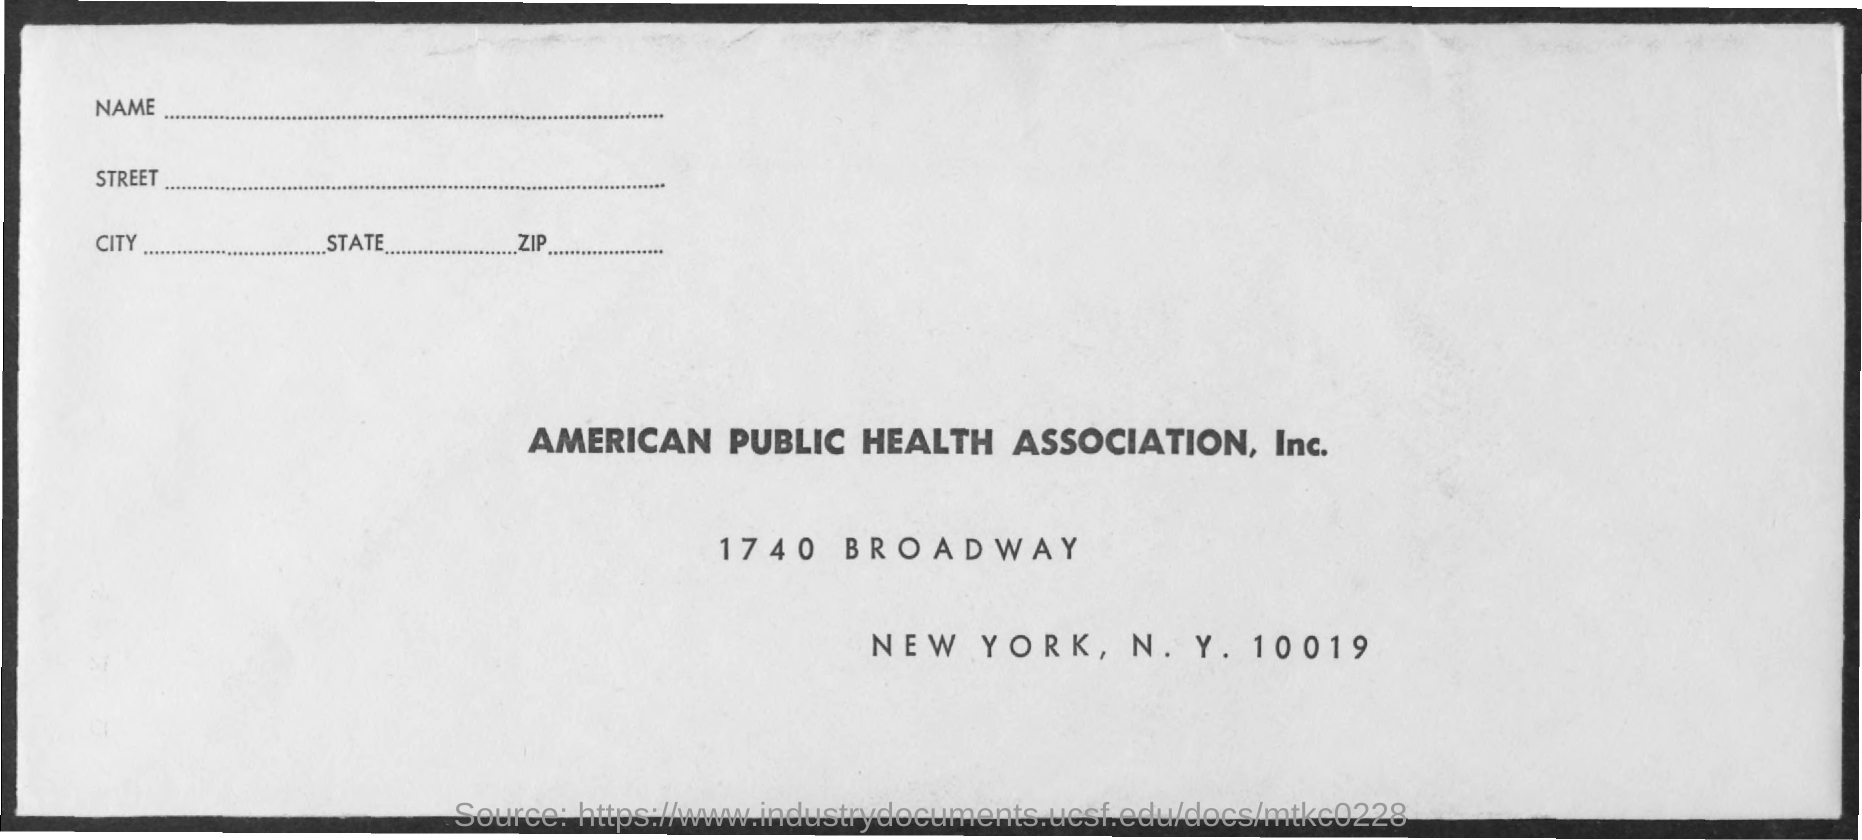Highlight a few significant elements in this photo. The city mentioned in the document is New York. The American Public Health Association, Inc. is named. 